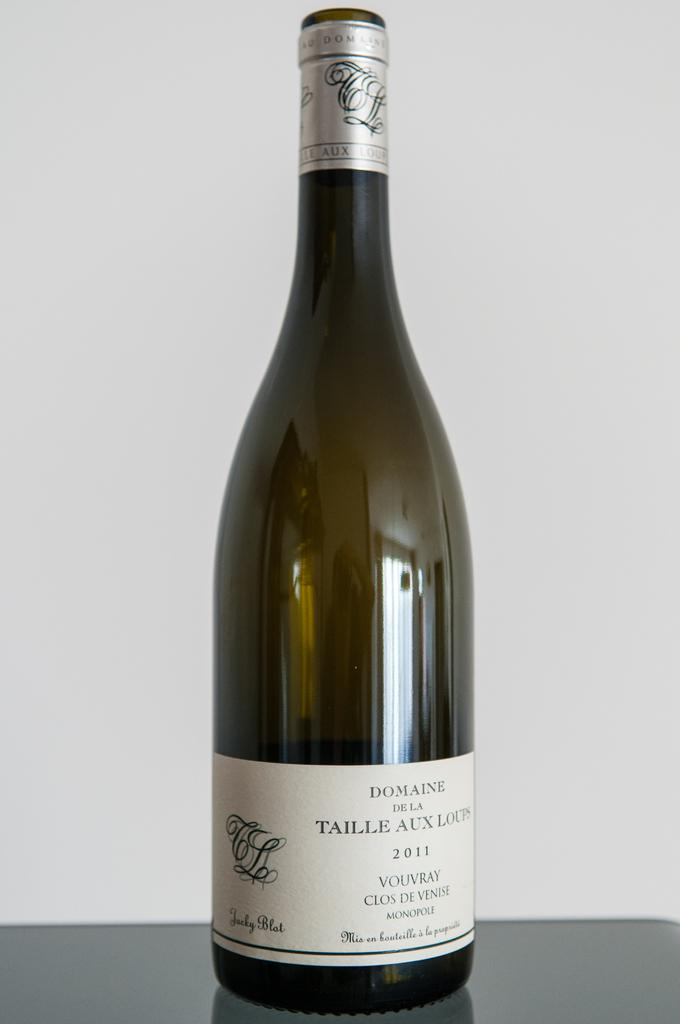Provide a one-sentence caption for the provided image. An uncorked bottle of wine form the year 2011 that says "Domaine De la Taille Au Loups". 